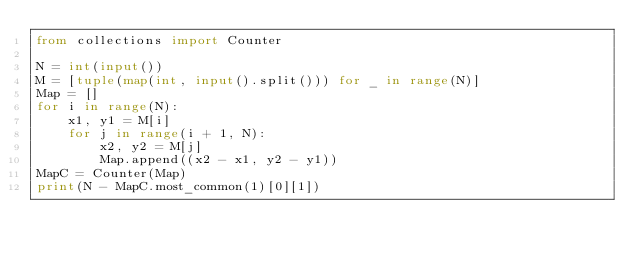<code> <loc_0><loc_0><loc_500><loc_500><_Python_>from collections import Counter

N = int(input())
M = [tuple(map(int, input().split())) for _ in range(N)]
Map = []
for i in range(N):
    x1, y1 = M[i]
    for j in range(i + 1, N):
        x2, y2 = M[j]
        Map.append((x2 - x1, y2 - y1))
MapC = Counter(Map)
print(N - MapC.most_common(1)[0][1])



</code> 